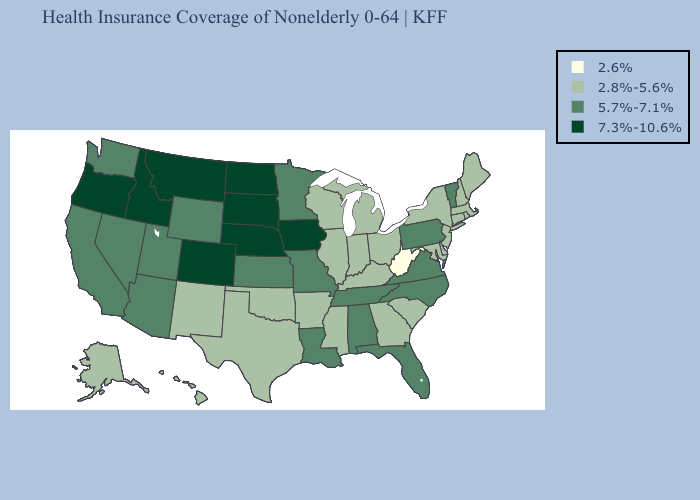Name the states that have a value in the range 5.7%-7.1%?
Answer briefly. Alabama, Arizona, California, Florida, Kansas, Louisiana, Minnesota, Missouri, Nevada, North Carolina, Pennsylvania, Tennessee, Utah, Vermont, Virginia, Washington, Wyoming. Which states have the lowest value in the South?
Short answer required. West Virginia. Which states have the highest value in the USA?
Quick response, please. Colorado, Idaho, Iowa, Montana, Nebraska, North Dakota, Oregon, South Dakota. Does Louisiana have the same value as Alaska?
Keep it brief. No. Is the legend a continuous bar?
Give a very brief answer. No. What is the value of Maine?
Give a very brief answer. 2.8%-5.6%. Does Colorado have the same value as Iowa?
Be succinct. Yes. What is the value of Virginia?
Quick response, please. 5.7%-7.1%. Which states have the lowest value in the USA?
Quick response, please. West Virginia. What is the highest value in states that border Tennessee?
Answer briefly. 5.7%-7.1%. Name the states that have a value in the range 2.6%?
Quick response, please. West Virginia. Name the states that have a value in the range 2.6%?
Answer briefly. West Virginia. What is the highest value in the USA?
Answer briefly. 7.3%-10.6%. Among the states that border Utah , which have the highest value?
Short answer required. Colorado, Idaho. 